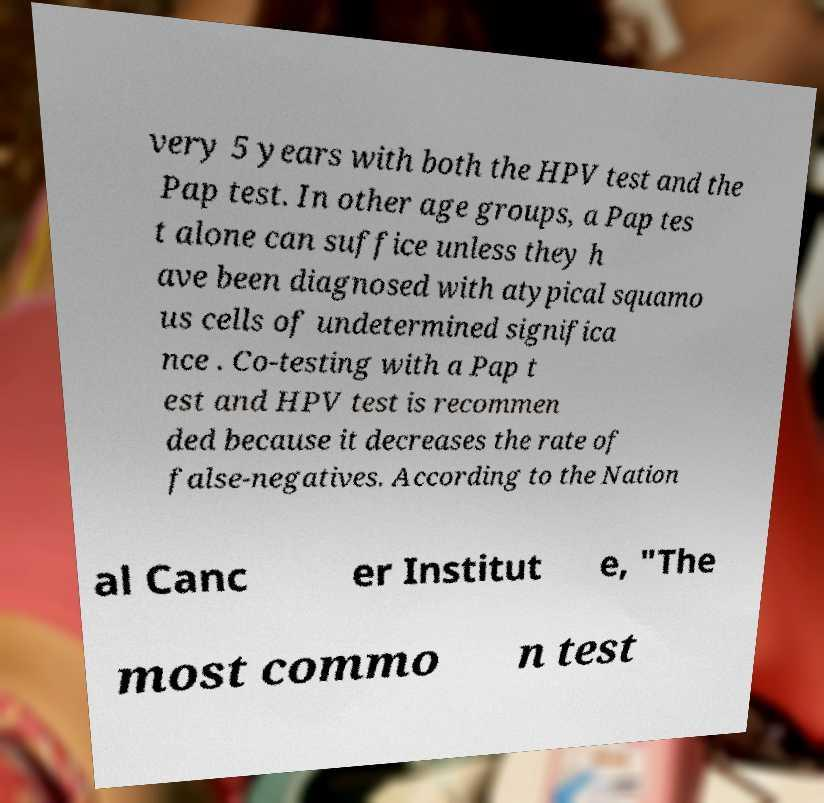There's text embedded in this image that I need extracted. Can you transcribe it verbatim? very 5 years with both the HPV test and the Pap test. In other age groups, a Pap tes t alone can suffice unless they h ave been diagnosed with atypical squamo us cells of undetermined significa nce . Co-testing with a Pap t est and HPV test is recommen ded because it decreases the rate of false-negatives. According to the Nation al Canc er Institut e, "The most commo n test 